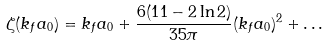Convert formula to latex. <formula><loc_0><loc_0><loc_500><loc_500>\zeta ( k _ { f } a _ { 0 } ) = k _ { f } a _ { 0 } + \frac { 6 ( 1 1 - 2 \ln 2 ) } { 3 5 \pi } ( k _ { f } a _ { 0 } ) ^ { 2 } + \dots</formula> 